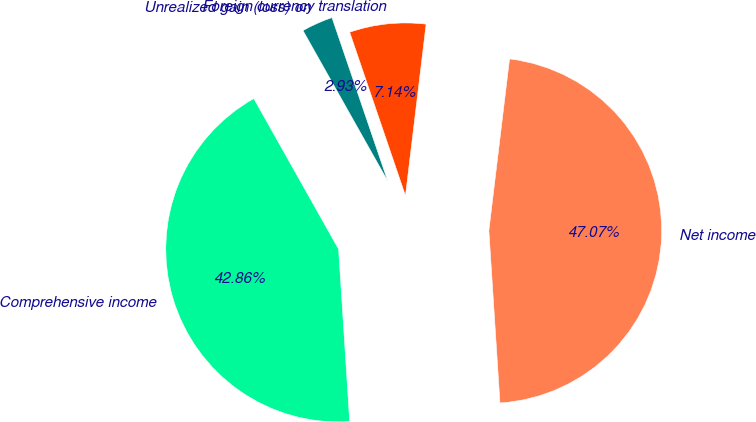Convert chart. <chart><loc_0><loc_0><loc_500><loc_500><pie_chart><fcel>Net income<fcel>Foreign currency translation<fcel>Unrealized gain (loss) on<fcel>Comprehensive income<nl><fcel>47.07%<fcel>7.14%<fcel>2.93%<fcel>42.86%<nl></chart> 